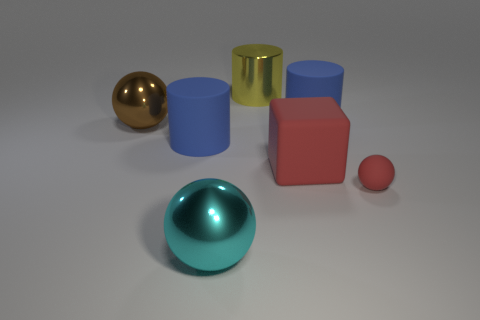Add 2 large cyan shiny objects. How many objects exist? 9 Subtract all large metallic cylinders. How many cylinders are left? 2 Subtract 1 blocks. How many blocks are left? 0 Add 7 big matte blocks. How many big matte blocks are left? 8 Add 7 green shiny cylinders. How many green shiny cylinders exist? 7 Subtract all red spheres. How many spheres are left? 2 Subtract 0 gray cylinders. How many objects are left? 7 Subtract all cubes. How many objects are left? 6 Subtract all yellow blocks. Subtract all brown balls. How many blocks are left? 1 Subtract all green cubes. How many cyan balls are left? 1 